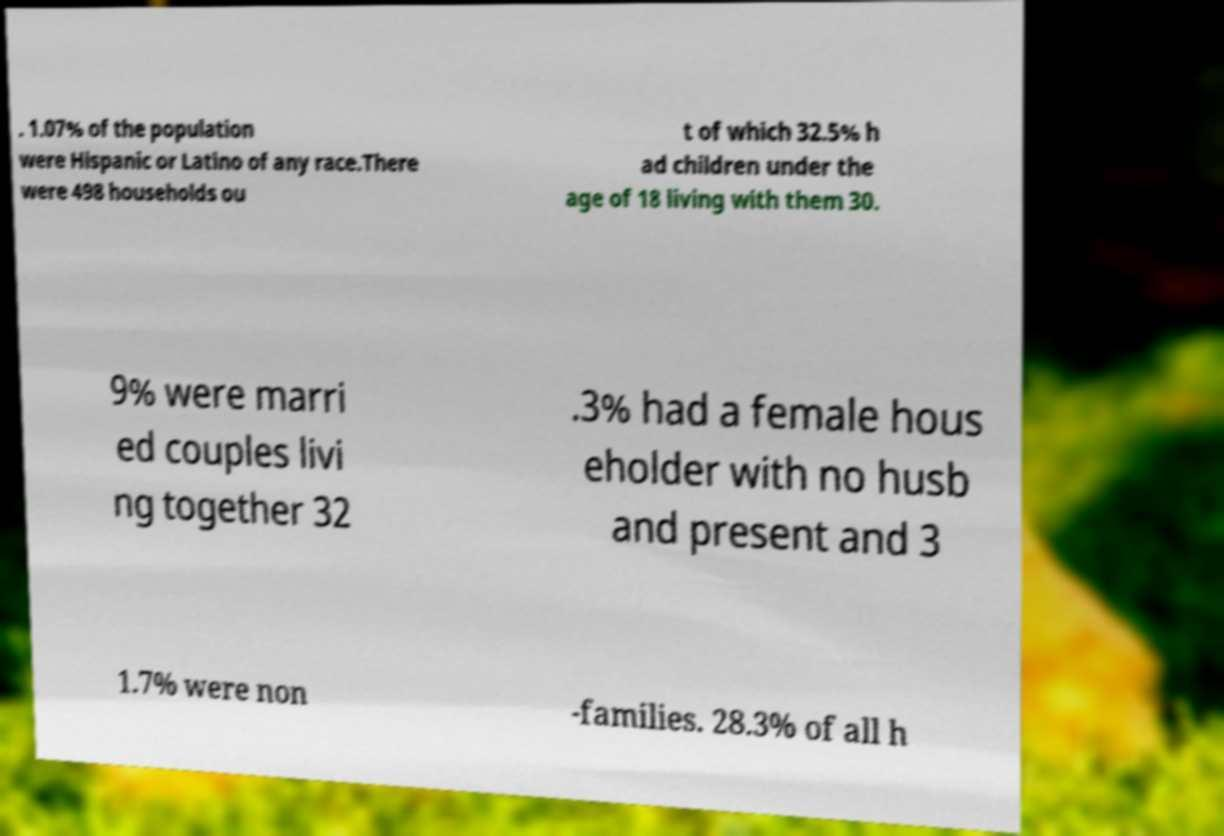Please identify and transcribe the text found in this image. . 1.07% of the population were Hispanic or Latino of any race.There were 498 households ou t of which 32.5% h ad children under the age of 18 living with them 30. 9% were marri ed couples livi ng together 32 .3% had a female hous eholder with no husb and present and 3 1.7% were non -families. 28.3% of all h 